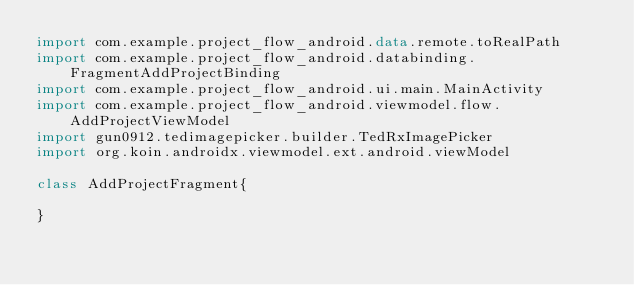Convert code to text. <code><loc_0><loc_0><loc_500><loc_500><_Kotlin_>import com.example.project_flow_android.data.remote.toRealPath
import com.example.project_flow_android.databinding.FragmentAddProjectBinding
import com.example.project_flow_android.ui.main.MainActivity
import com.example.project_flow_android.viewmodel.flow.AddProjectViewModel
import gun0912.tedimagepicker.builder.TedRxImagePicker
import org.koin.androidx.viewmodel.ext.android.viewModel

class AddProjectFragment{

}</code> 